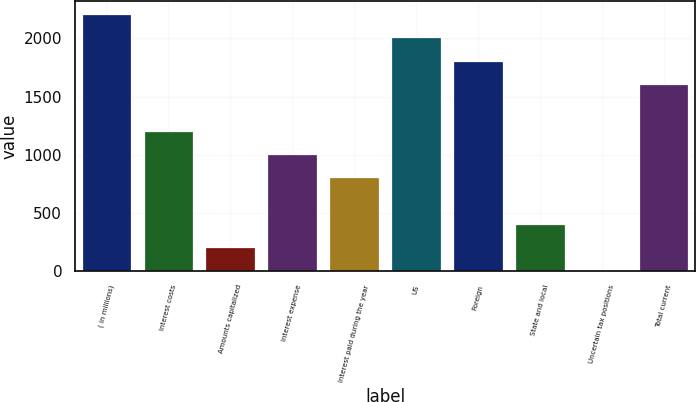Convert chart. <chart><loc_0><loc_0><loc_500><loc_500><bar_chart><fcel>( in millions)<fcel>Interest costs<fcel>Amounts capitalized<fcel>Interest expense<fcel>Interest paid during the year<fcel>US<fcel>Foreign<fcel>State and local<fcel>Uncertain tax positions<fcel>Total current<nl><fcel>2209.64<fcel>1206.44<fcel>203.24<fcel>1005.8<fcel>805.16<fcel>2009<fcel>1808.36<fcel>403.88<fcel>2.6<fcel>1607.72<nl></chart> 